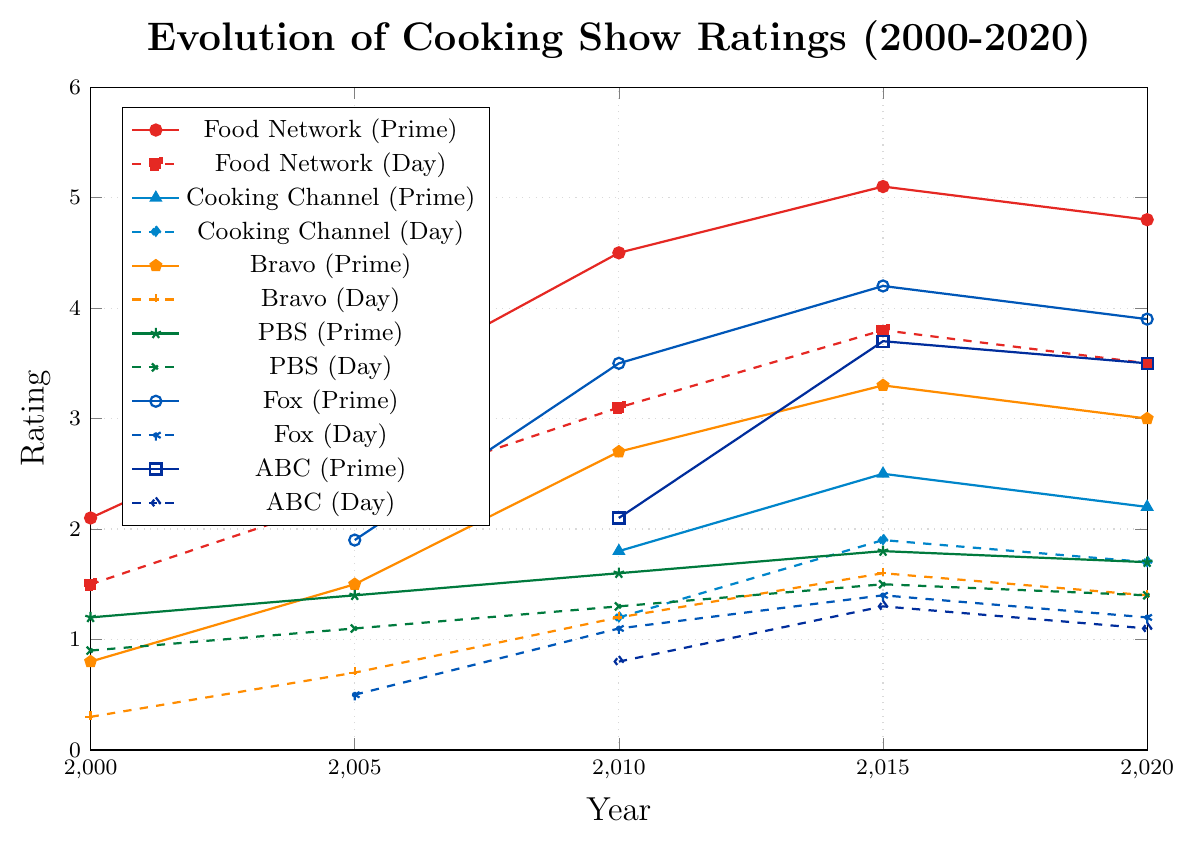Which network had the highest rating in 2020 for the primetime slot? Look at the lines representing primetime slots in 2020. The highest point is for Food Network (Prime) at 4.8.
Answer: Food Network How did the ratings for Cooking Channel (Daytime) change from 2010 to 2020? Observe the line for Cooking Channel (Daytime) from 2010 to 2020. It starts at 1.2 in 2010, rises to 1.9 in 2015, and slightly decreases to 1.7 in 2020.
Answer: Increased from 1.2 to 1.9 and then decreased to 1.7 Which network showed the most consistent growth in ratings for the primetime slot from 2000 to 2020? Examine the trends of all primetime lines. PBS (Prime) shows a steady but gradual increase with no big spikes or drops.
Answer: PBS For Bravo, was there a larger increase in ratings for the daytime or primetime slot from 2000 to 2020? Bravo's primetime rating increased from 0.8 to 3.0 (2.2 point increase), while the daytime rating increased from 0.3 to 1.4 (1.1 point increase).
Answer: Primetime What is the difference in ratings between Food Network (Primetime) and Bravo (Primetime) in 2015? Food Network (Prime) rating in 2015 is 5.1 and Bravo (Prime) rating is 3.3. The difference is 5.1 - 3.3 = 1.8.
Answer: 1.8 On which network did cooking shows in the daytime slot see the highest rating in 2010? Compare the ratings in the daytime slot for all networks in 2010. Food Network (Daytime) had the highest rating at 3.1.
Answer: Food Network Which network experienced the least change in ratings for the daytime slot between 2000 and 2020? Observe the lines for the daytime slots. PBS (Day) changes from 0.9 in 2000 to 1.4 in 2020, a difference of only 0.5.
Answer: PBS Considering primetime ratings, which network had the largest drop in ratings from 2015 to 2020? Look at the primetime ratings changes from 2015 to 2020. Fox (Prime) decreased from 4.2 to 3.9, a drop of 0.3.
Answer: Fox How do the primetime ratings of ABC compare to Fox in 2020? ABC (Prime) has a rating of 3.5 in 2020, and Fox (Prime) has a rating of 3.9.
Answer: Fox is higher 